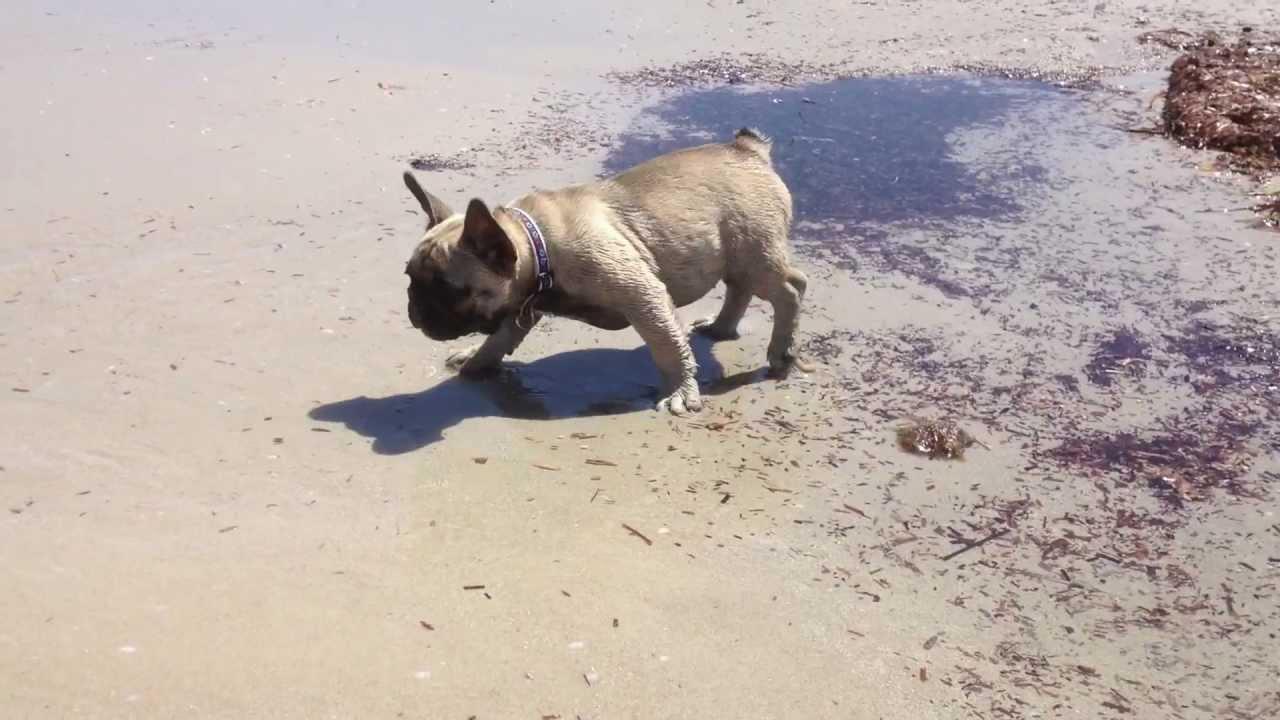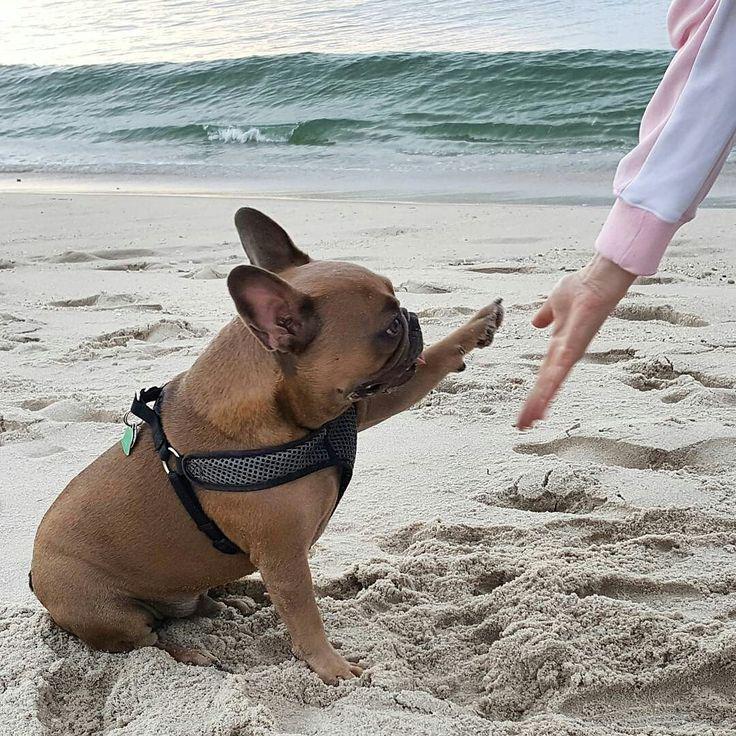The first image is the image on the left, the second image is the image on the right. For the images shown, is this caption "An image shows a brownish dog in profile, wearing a harness." true? Answer yes or no. Yes. The first image is the image on the left, the second image is the image on the right. For the images shown, is this caption "Four dogs are on the beach with no human visible." true? Answer yes or no. No. 